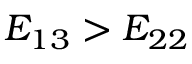Convert formula to latex. <formula><loc_0><loc_0><loc_500><loc_500>E _ { 1 3 } > E _ { 2 2 }</formula> 